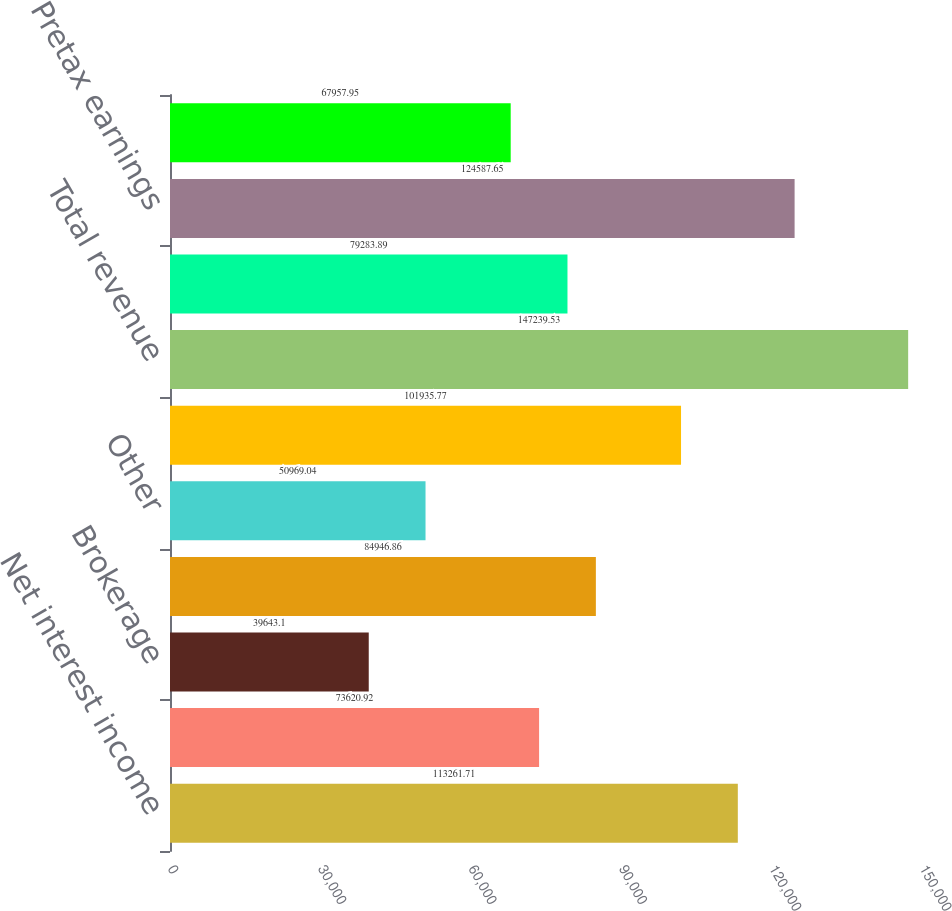Convert chart to OTSL. <chart><loc_0><loc_0><loc_500><loc_500><bar_chart><fcel>Net interest income<fcel>Service charges on deposits<fcel>Brokerage<fcel>Consumer services<fcel>Other<fcel>Total noninterest income<fcel>Total revenue<fcel>Provision for credit losses<fcel>Pretax earnings<fcel>Earnings<nl><fcel>113262<fcel>73620.9<fcel>39643.1<fcel>84946.9<fcel>50969<fcel>101936<fcel>147240<fcel>79283.9<fcel>124588<fcel>67957.9<nl></chart> 